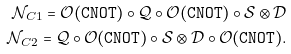Convert formula to latex. <formula><loc_0><loc_0><loc_500><loc_500>\mathcal { N } _ { C 1 } = \mathcal { O } ( { \tt C N O T } ) \circ \mathcal { Q } \circ \mathcal { O } ( { \tt C N O T } ) \circ \mathcal { S } \otimes \mathcal { D } \\ \mathcal { N } _ { C 2 } = \mathcal { Q } \circ \mathcal { O } ( { \tt C N O T } ) \circ \mathcal { S } \otimes \mathcal { D } \circ \mathcal { O } ( { \tt C N O T } ) .</formula> 